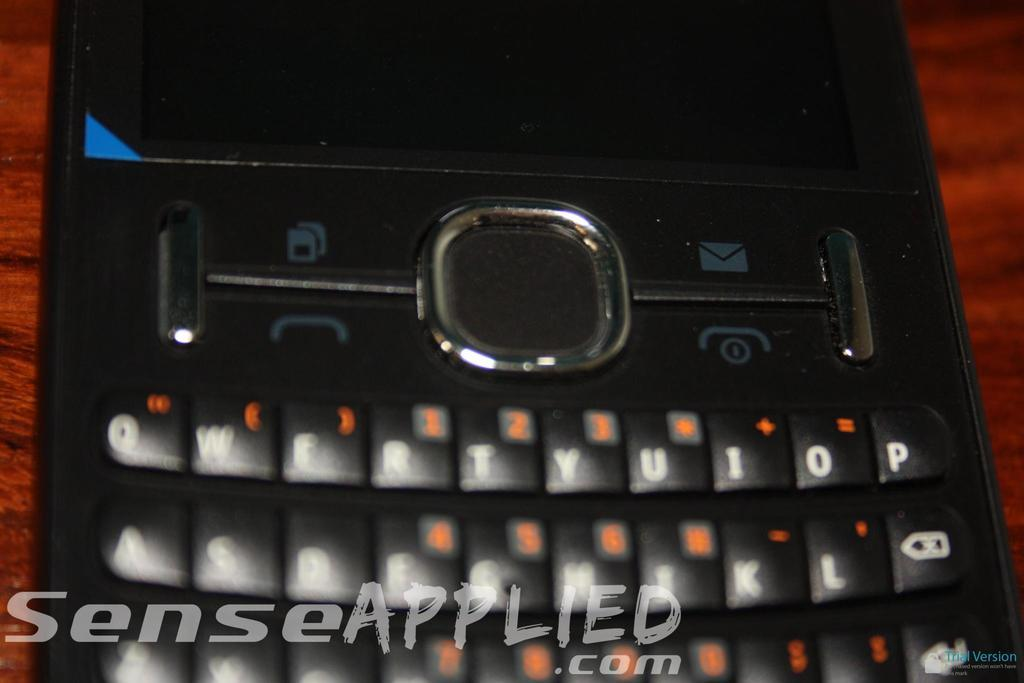<image>
Present a compact description of the photo's key features. A black device with senseapllied.com imposed on the picture. 